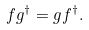Convert formula to latex. <formula><loc_0><loc_0><loc_500><loc_500>f g ^ { \dag } = g f ^ { \dag } .</formula> 